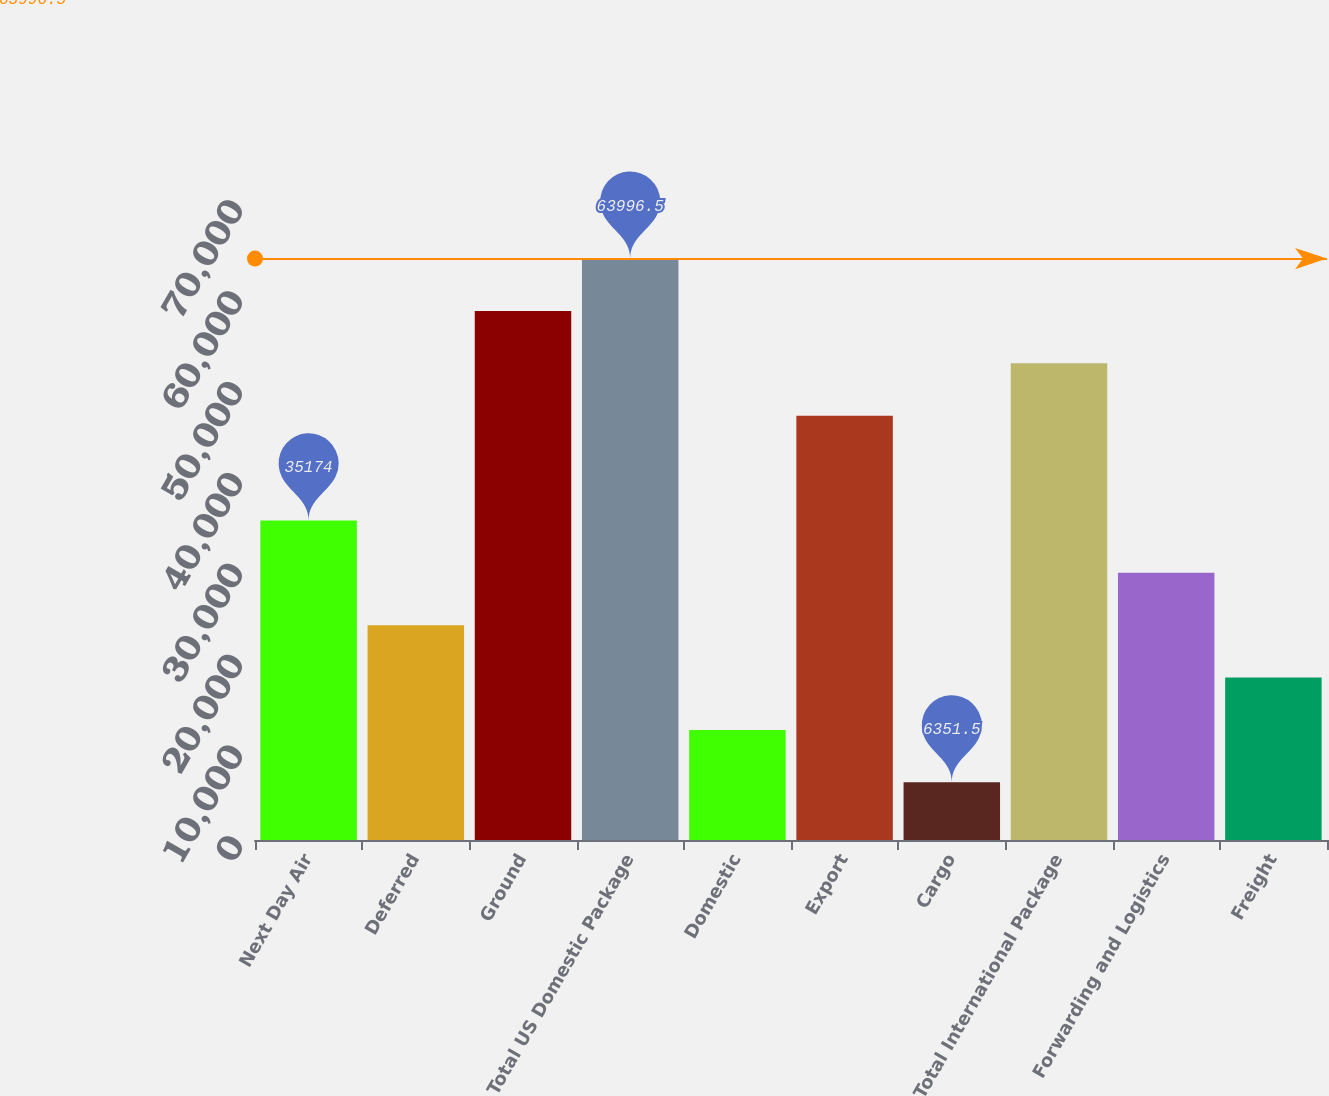Convert chart to OTSL. <chart><loc_0><loc_0><loc_500><loc_500><bar_chart><fcel>Next Day Air<fcel>Deferred<fcel>Ground<fcel>Total US Domestic Package<fcel>Domestic<fcel>Export<fcel>Cargo<fcel>Total International Package<fcel>Forwarding and Logistics<fcel>Freight<nl><fcel>35174<fcel>23645<fcel>58232<fcel>63996.5<fcel>12116<fcel>46703<fcel>6351.5<fcel>52467.5<fcel>29409.5<fcel>17880.5<nl></chart> 